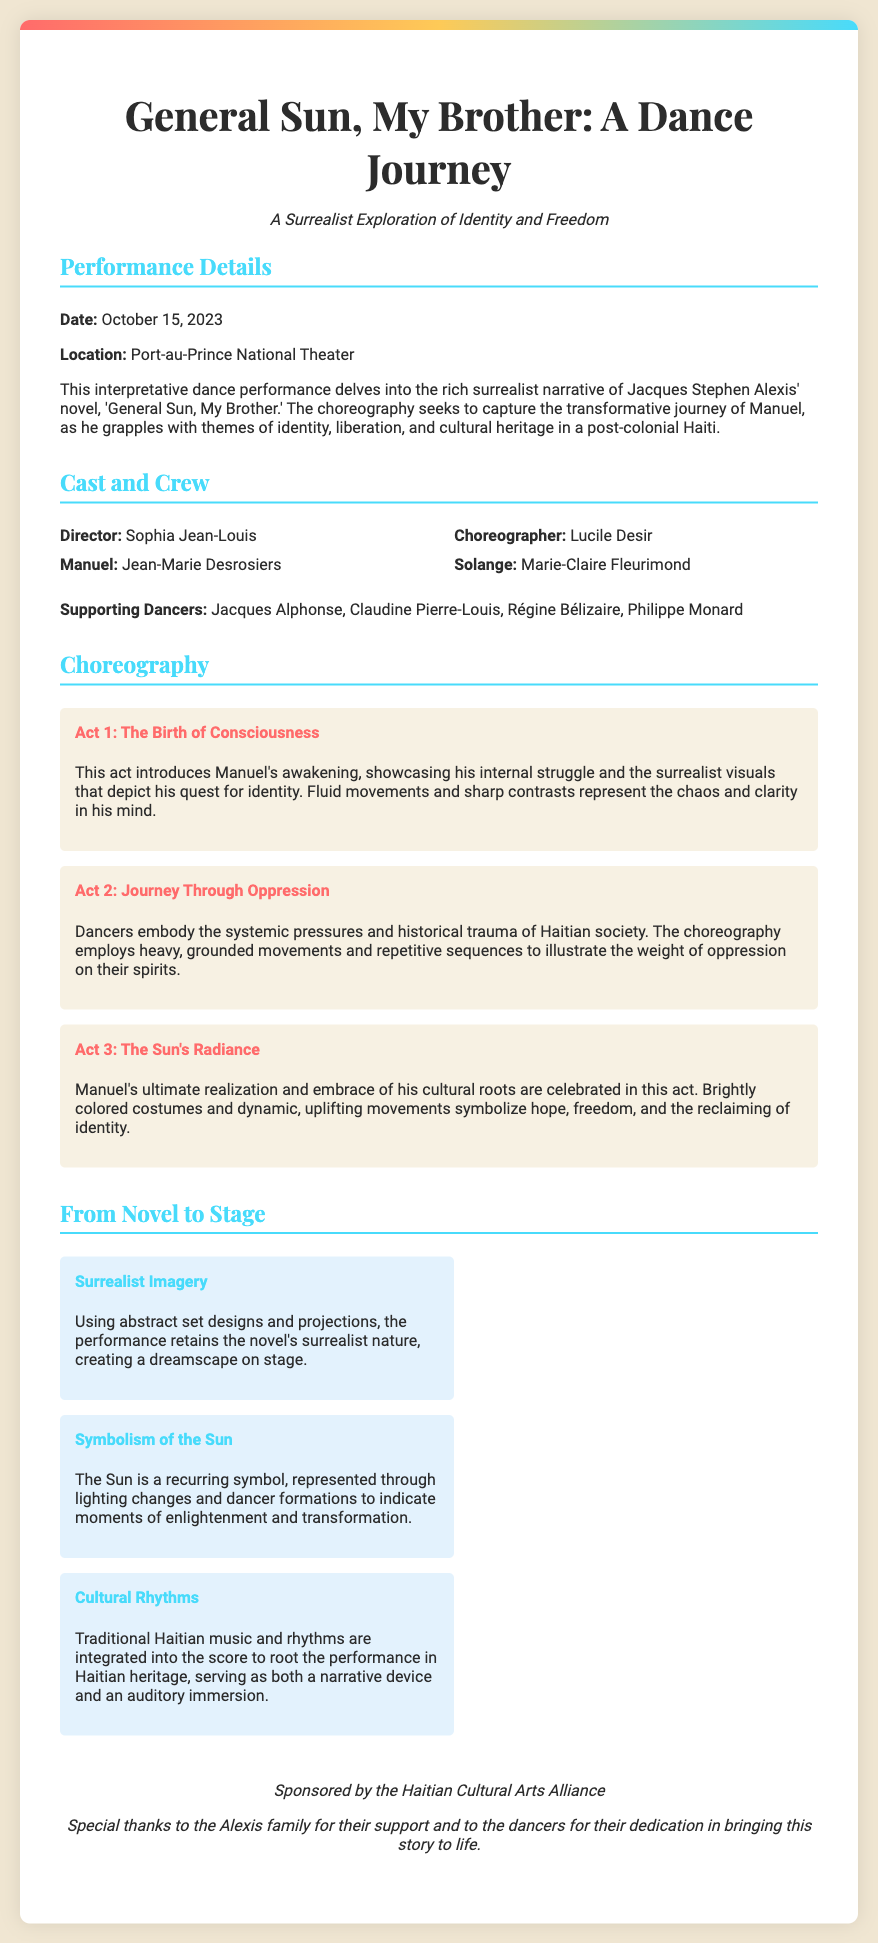What is the title of the performance? The title of the performance is provided in the header of the Playbill.
Answer: General Sun, My Brother: A Dance Journey Who is the choreographer? The choreographer is listed in the cast and crew section.
Answer: Lucile Desir When is the performance date? The performance date is stated in the performance details section.
Answer: October 15, 2023 What is the location of the performance? The location is indicated in the performance details section.
Answer: Port-au-Prince National Theater What theme does the performance explore? The theme is described in the subtitle and performance details sections.
Answer: Identity and Freedom Which act represents "The Sun's Radiance"? The act title is mentioned under the choreography section.
Answer: Act 3 What supports the adaptation to the stage? The adaptation highlights provide insight on how the novel is represented.
Answer: Surrealist Imagery Which artistic element symbolizes moments of enlightenment? The document highlights specific symbols within the narrative adaptation.
Answer: The Sun Who directed the performance? The director's name is provided in the cast and crew section.
Answer: Sophia Jean-Louis 